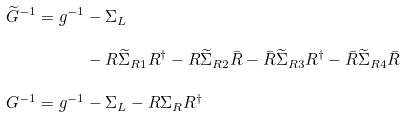Convert formula to latex. <formula><loc_0><loc_0><loc_500><loc_500>\widetilde { G } ^ { - 1 } = g ^ { - 1 } & - \Sigma _ { L } \\ & - R \widetilde { \Sigma } _ { R 1 } R ^ { \dag } - R \widetilde { \Sigma } _ { R 2 } \bar { R } - \bar { R } \widetilde { \Sigma } _ { R 3 } R ^ { \dag } - \bar { R } \widetilde { \Sigma } _ { R 4 } \bar { R } \\ G ^ { - 1 } = g ^ { - 1 } & - \Sigma _ { L } - R \Sigma _ { R } R ^ { \dag }</formula> 